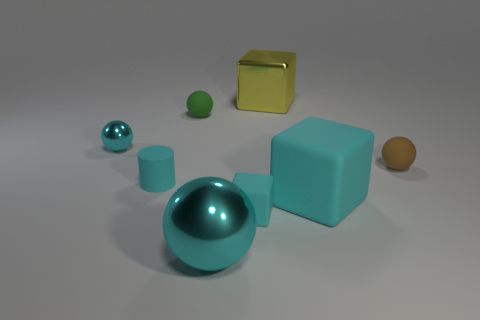Does the cylinder have the same color as the tiny rubber block?
Offer a terse response. Yes. There is a big metallic thing that is the same color as the small cylinder; what is its shape?
Your answer should be very brief. Sphere. There is a cylinder that is the same color as the tiny metal sphere; what size is it?
Your answer should be compact. Small. How many objects are either big yellow shiny things or cyan things?
Your answer should be compact. 6. What is the size of the cyan matte thing that is to the right of the shiny block?
Offer a terse response. Large. Is there any other thing that is the same size as the green thing?
Make the answer very short. Yes. What color is the metal thing that is both to the right of the tiny cyan ball and behind the cylinder?
Your response must be concise. Yellow. Is the material of the large cyan object that is on the left side of the big cyan matte cube the same as the green object?
Provide a short and direct response. No. There is a small cylinder; does it have the same color as the matte cube that is on the left side of the big yellow block?
Ensure brevity in your answer.  Yes. There is a tiny green thing; are there any tiny cyan metallic objects behind it?
Ensure brevity in your answer.  No. 